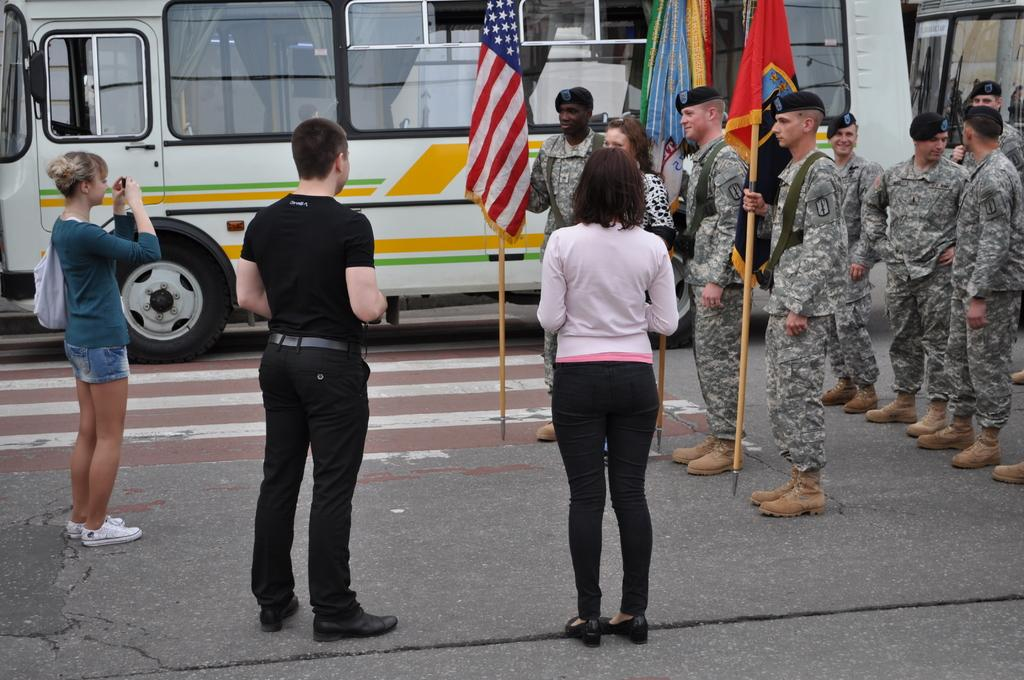How many people are in the image? There is a group of people in the image, but the exact number is not specified. Where are the people located in the image? The people are standing on the road in the image. What else can be seen in the image besides the group of people? There is a bus, bags, and flags in the image. Are there any other objects in the image that are not specified? Yes, there are some unspecified objects in the image. What type of wool is being used to make the cup in the image? There is no cup or wool present in the image. 